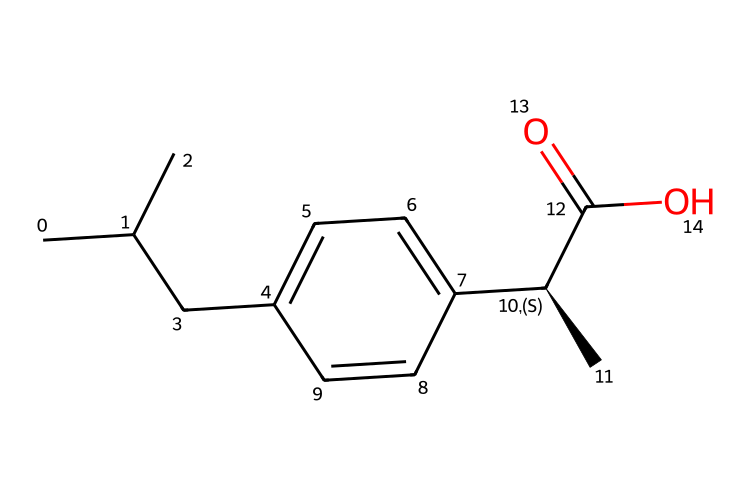What is the primary functional group in ibuprofen? The primary functional group in ibuprofen is the carboxylic acid group, identifiable by the -C(=O)O portion of the SMILES representation. This indicates that it has acidic properties.
Answer: carboxylic acid How many carbon atoms are there in ibuprofen? By analyzing the SMILES, we count a total of 13 carbon atoms represented by "C" symbols, including branches and the aromatic ring.
Answer: 13 Is this compound aromatic? Yes, this compound contains a benzene-like structure indicated by "c" in the SMILES, which signifies that it has a delocalized pi electron system typical of aromatic compounds.
Answer: yes What type of aliphatic chain is present in ibuprofen? The aliphatic portion consists of a branched chain due to the presence of the "CC(C)" at the beginning of the SMILES, indicating that there's a carbon chain with branches, typical of aliphatic compounds.
Answer: branched How many double bonds are present in ibuprofen? Upon inspecting the SMILES, there is one double bond between the carbon and oxygen in the carboxylic acid group (-C(=O)O), accounting for the only double bond in the structure.
Answer: 1 What stereochemistry feature is present in ibuprofen? The SMILES shows a "[C@H]" indicating that there is one chiral center in ibuprofen, allowing for stereoisomerism, which is significant in the biological activity of the compound.
Answer: chiral center 